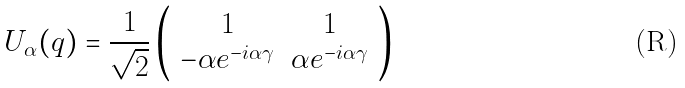<formula> <loc_0><loc_0><loc_500><loc_500>U _ { \alpha } ( q ) = \frac { 1 } { \sqrt { 2 } } \left ( \begin{array} { c c } 1 & 1 \\ - \alpha e ^ { - i \alpha \gamma } & \alpha e ^ { - i \alpha \gamma } \end{array} \right )</formula> 